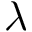Convert formula to latex. <formula><loc_0><loc_0><loc_500><loc_500>\lambda</formula> 